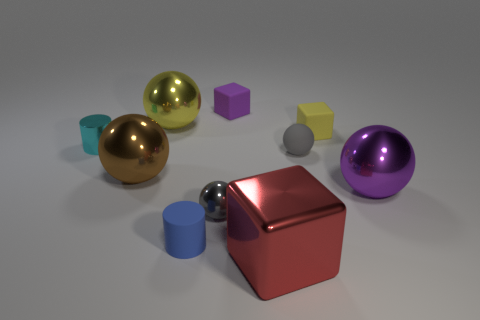The tiny rubber sphere has what color?
Provide a short and direct response. Gray. How many gray cylinders are there?
Offer a terse response. 0. How many other big blocks are the same color as the shiny cube?
Make the answer very short. 0. There is a matte thing to the left of the purple block; does it have the same shape as the small shiny object behind the brown metal sphere?
Make the answer very short. Yes. What is the color of the tiny object that is in front of the tiny ball left of the purple object that is left of the tiny yellow object?
Your answer should be compact. Blue. What is the color of the small metal object behind the purple sphere?
Offer a very short reply. Cyan. There is a matte cylinder that is the same size as the cyan metal cylinder; what is its color?
Your answer should be very brief. Blue. Do the purple ball and the purple rubber thing have the same size?
Offer a terse response. No. There is a matte ball; what number of gray rubber objects are on the left side of it?
Your answer should be compact. 0. What number of things are tiny cylinders that are behind the blue matte cylinder or tiny green rubber spheres?
Keep it short and to the point. 1. 